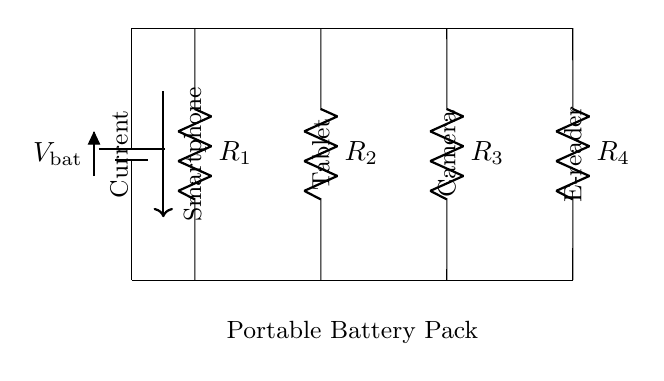What is the total number of resistors in the circuit? The diagram shows four resistors labeled as R1, R2, R3, and R4 connected in parallel. The count of these components gives the total number of resistors.
Answer: Four What devices can be powered by this circuit? The circuit diagram indicates four devices: a smartphone, a tablet, a camera, and an e-reader. Each device corresponds to one of the resistors.
Answer: Smartphone, tablet, camera, e-reader What is the configuration of the circuit? The resistors are connected in a parallel configuration, meaning that all components share the same voltage and the current can flow through multiple paths to the devices.
Answer: Parallel What is the purpose of the battery in the circuit? The battery provides the necessary voltage supply for the entire circuit and ensures that each connected device receives power as intended. It is the source of energy for the parallel circuit.
Answer: Voltage supply Which resistor is connected to the smartphone? The lifestyle element in this circuit specifically links the smartphone to R1. By locating the label next to the resistor, we can identify the correct component associated with the smartphone.
Answer: R1 What happens to the total current if one device is disconnected? In a parallel circuit, if one device (e.g., any of the resistors) is disconnected, the total current may increase through the remaining connected devices since the overall resistance of the circuit decreases.
Answer: Increases 